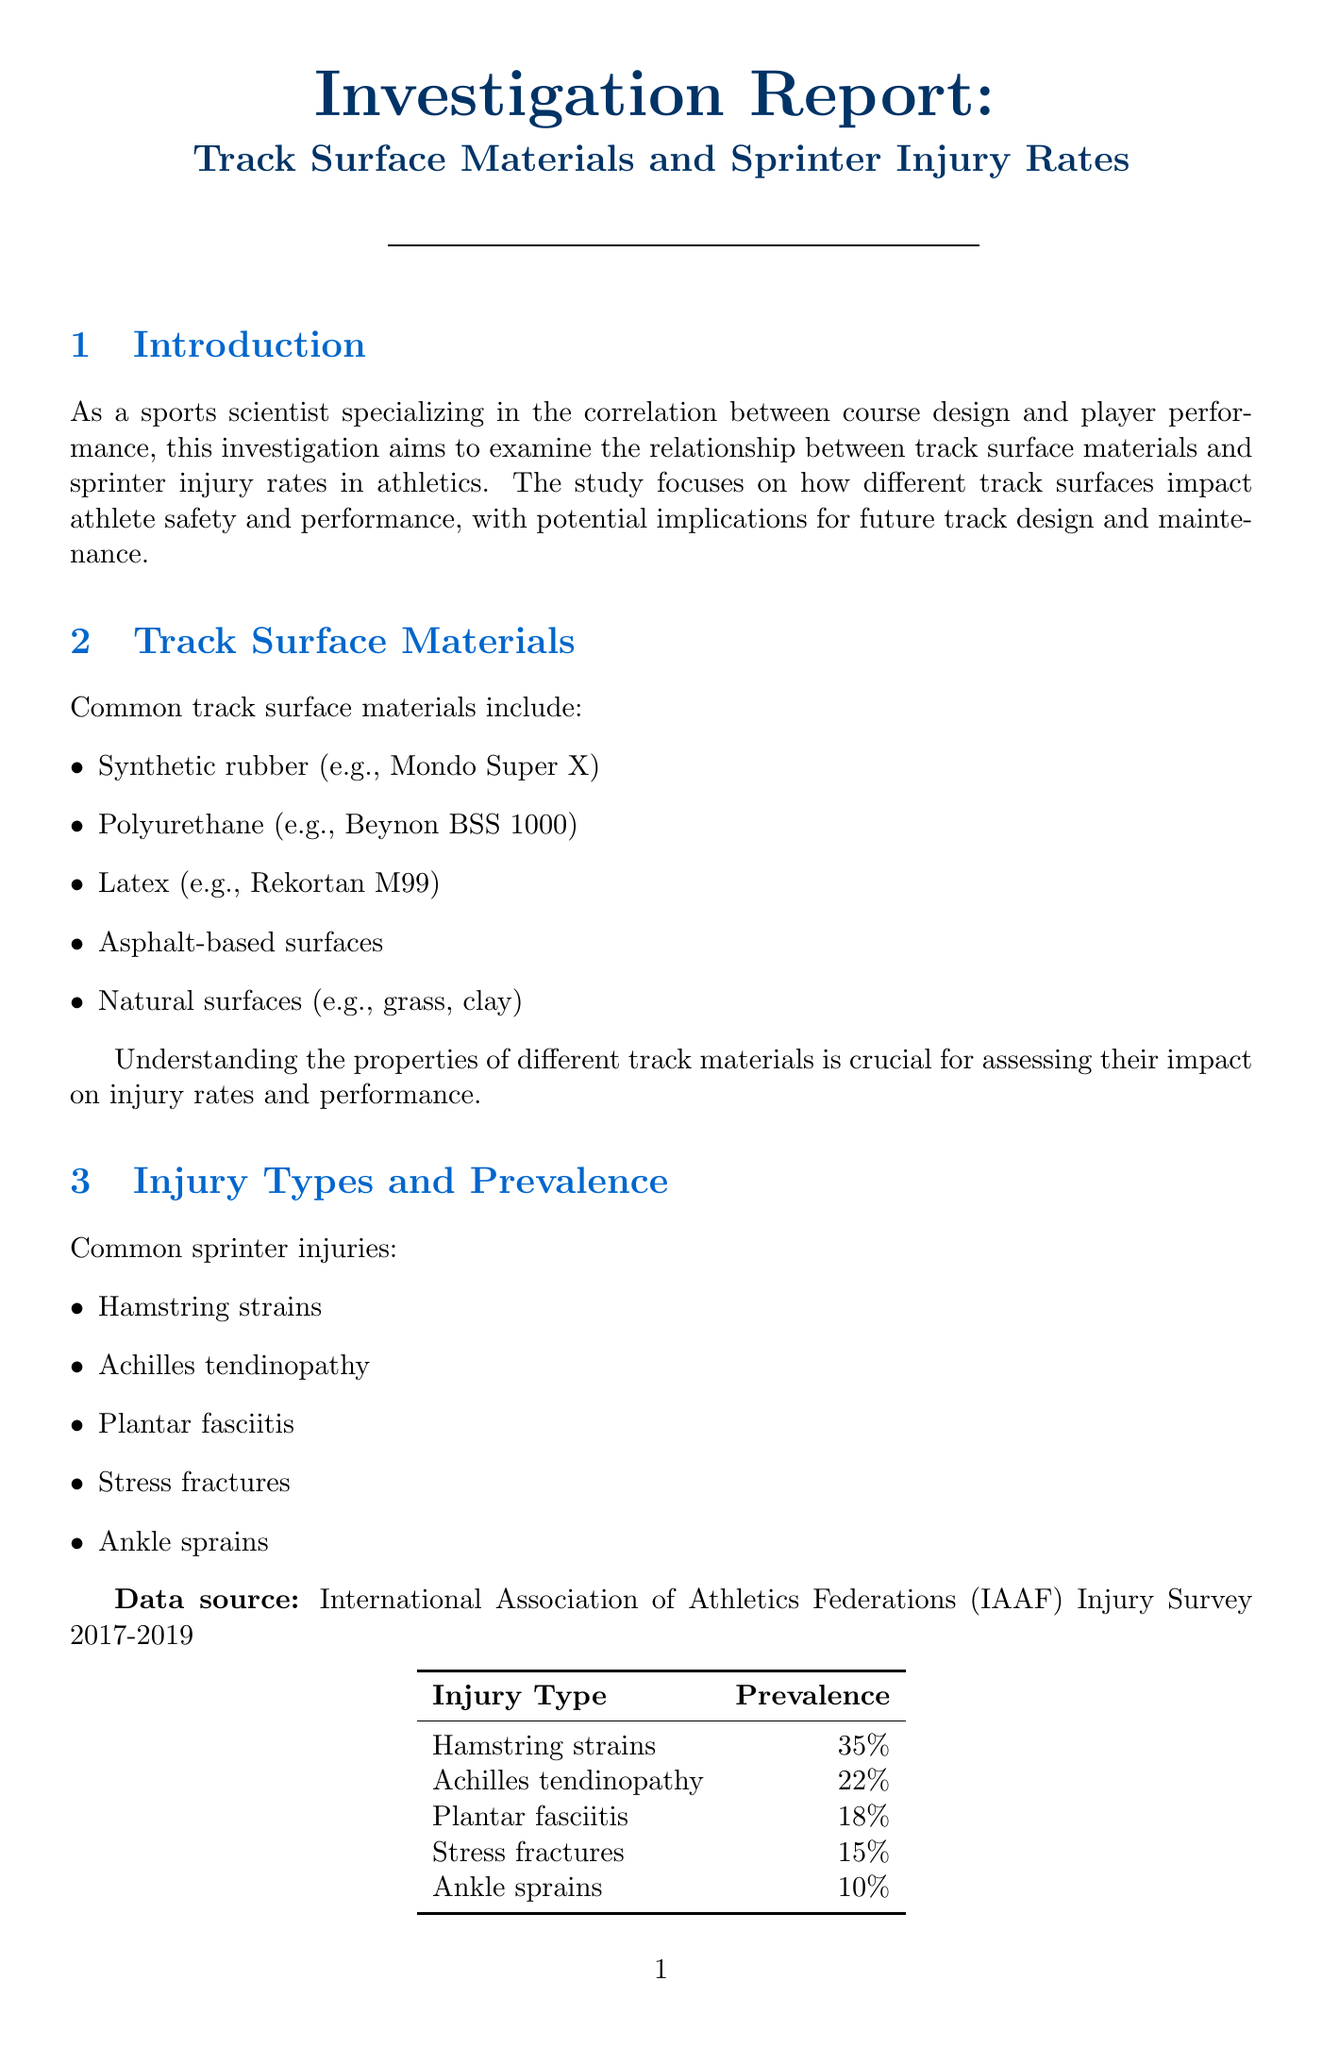what is the main focus of the investigation? The investigation aims to examine the relationship between track surface materials and sprinter injury rates in athletics.
Answer: relationship between track surface materials and sprinter injury rates what are the common types of sprinter injuries? The document lists various types of sprinter injuries, which include hamstring strains, Achilles tendinopathy, and others.
Answer: hamstring strains, Achilles tendinopathy, plantar fasciitis, stress fractures, ankle sprains what is the injury rate reduction observed at the 2016 Rio Olympics? The document states the injury rate at the 2016 Rio Olympics was 12% lower than the previous Olympics.
Answer: 12% which track surface shows superior shock absorption? The document indicates that polyurethane tracks, such as Beynon BSS 1000, demonstrate superior shock absorption.
Answer: polyurethane tracks (e.g., Beynon BSS 1000) what percentage of injuries were hamstring strains according to the IAAF Injury Survey? The document specifies that hamstring strains accounted for 35% of injuries based on the IAAF Injury Survey.
Answer: 35% what is the recommendation for track surfaces? The recommendations suggest prioritizing synthetic rubber or polyurethane surfaces for competitive tracks.
Answer: synthetic rubber or polyurethane surfaces which biomechanical factor is affected by track surface? The document lists several factors, including ground reaction forces, which are affected by track surface.
Answer: ground reaction forces what type of surfaces show higher rates of ankle sprains? The document notes that natural surfaces, like grass and clay, show higher rates of ankle sprains.
Answer: natural surfaces (grass, clay) 